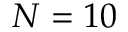Convert formula to latex. <formula><loc_0><loc_0><loc_500><loc_500>N = 1 0</formula> 